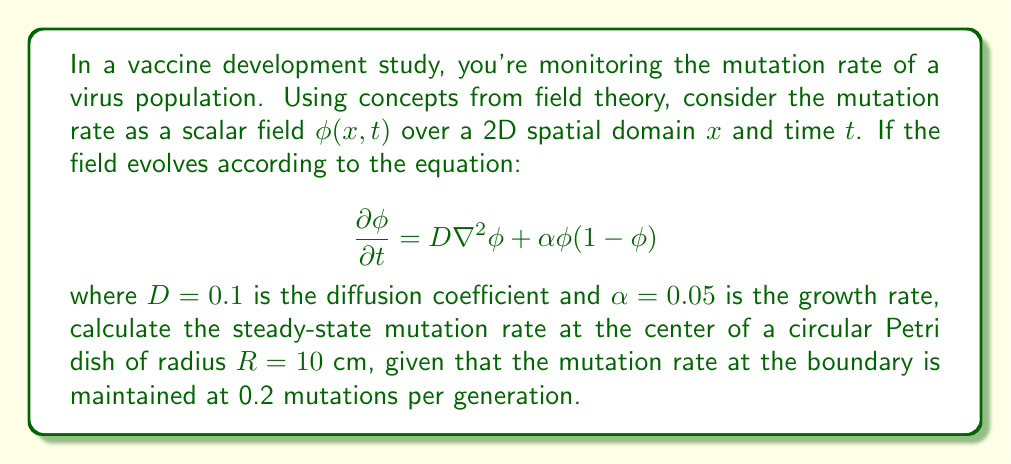Help me with this question. To solve this problem, we'll follow these steps:

1) In steady-state, the time derivative is zero: $\frac{\partial \phi}{\partial t} = 0$

2) The equation becomes:

   $$D\nabla^2\phi + \alpha\phi(1-\phi) = 0$$

3) In 2D polar coordinates, due to radial symmetry, this becomes:

   $$D\left(\frac{1}{r}\frac{d}{dr}\left(r\frac{d\phi}{dr}\right)\right) + \alpha\phi(1-\phi) = 0$$

4) Let $u = \frac{d\phi}{dr}$. Then $\frac{du}{dr} = \frac{d^2\phi}{dr^2}$

5) Substituting:

   $$D\left(\frac{1}{r}\frac{d}{dr}(ru)\right) + \alpha\phi(1-\phi) = 0$$

6) Expanding:

   $$D\left(\frac{u}{r} + \frac{du}{dr}\right) + \alpha\phi(1-\phi) = 0$$

7) At $r=0$ (center of the dish), symmetry requires $u=0$. Then:

   $$D\frac{du}{dr} + \alpha\phi(1-\phi) = 0$$

8) At steady-state, $\frac{du}{dr} = 0$ at $r=0$, so:

   $$\alpha\phi(1-\phi) = 0$$

9) This has two solutions: $\phi = 0$ or $\phi = 1$

10) Given the boundary condition $\phi(R) = 0.2$, we expect $\phi(0) > 0.2$, so $\phi(0) = 1$

Therefore, the steady-state mutation rate at the center of the Petri dish is 1 mutation per generation.
Answer: 1 mutation per generation 